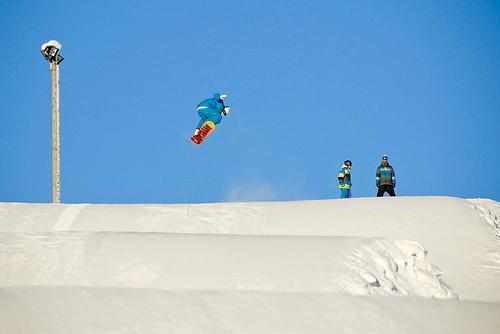How many people are snowboarding?
Give a very brief answer. 1. How many people are there?
Give a very brief answer. 3. How many people are standing on the ground?
Give a very brief answer. 2. How many people are in the air?
Give a very brief answer. 1. How many people are pictured?
Give a very brief answer. 3. 